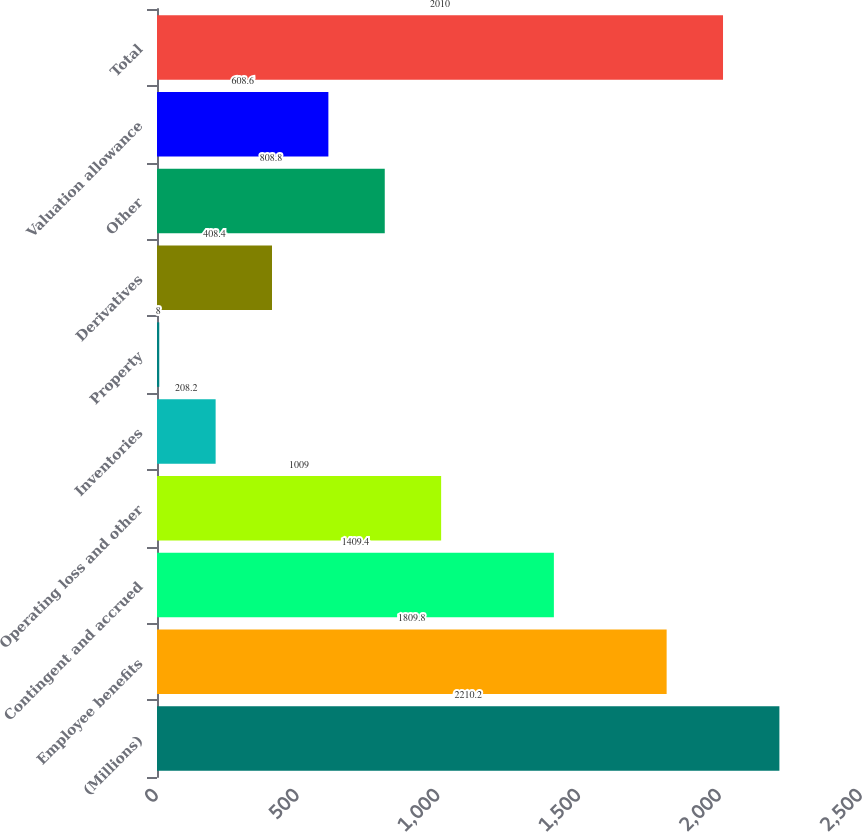Convert chart. <chart><loc_0><loc_0><loc_500><loc_500><bar_chart><fcel>(Millions)<fcel>Employee benefits<fcel>Contingent and accrued<fcel>Operating loss and other<fcel>Inventories<fcel>Property<fcel>Derivatives<fcel>Other<fcel>Valuation allowance<fcel>Total<nl><fcel>2210.2<fcel>1809.8<fcel>1409.4<fcel>1009<fcel>208.2<fcel>8<fcel>408.4<fcel>808.8<fcel>608.6<fcel>2010<nl></chart> 